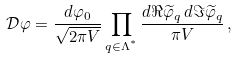<formula> <loc_0><loc_0><loc_500><loc_500>\mathcal { D } \varphi = \frac { d \varphi _ { 0 } } { \sqrt { 2 \pi V } } \prod _ { q \in \Lambda ^ { ^ { * } } } \frac { d \Re { \widetilde { \varphi } _ { q } } \, d \Im { \widetilde { \varphi } _ { q } } } { \pi V } \, ,</formula> 